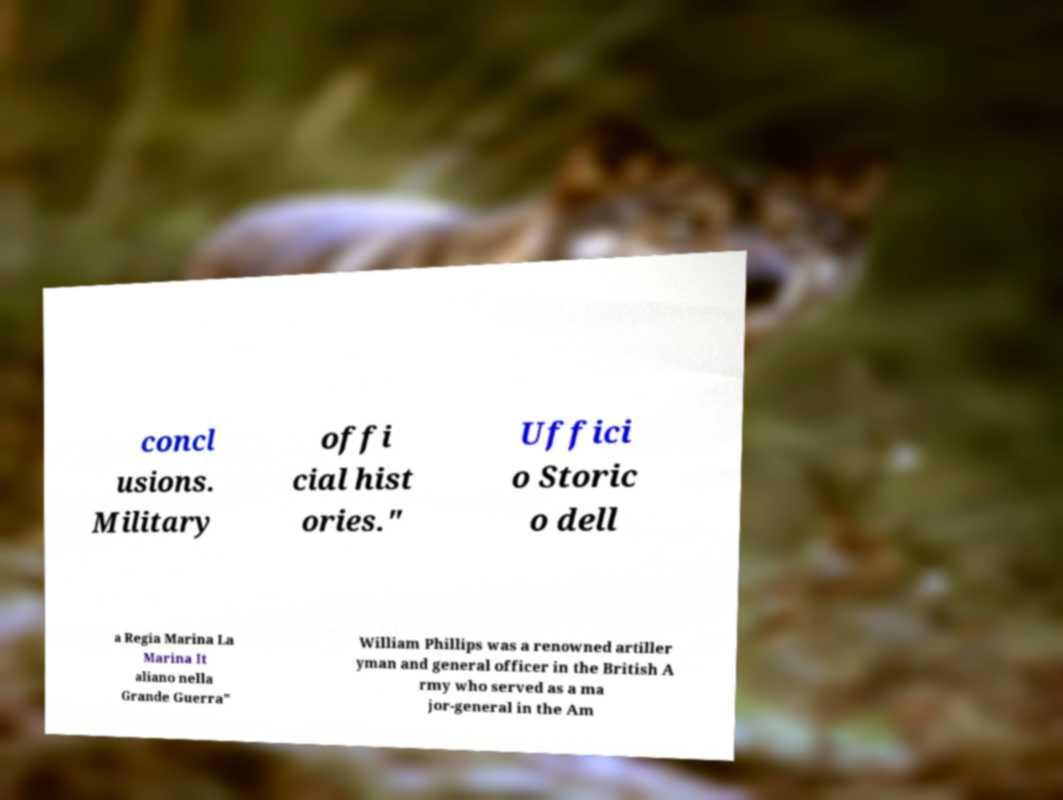There's text embedded in this image that I need extracted. Can you transcribe it verbatim? concl usions. Military offi cial hist ories." Uffici o Storic o dell a Regia Marina La Marina It aliano nella Grande Guerra" William Phillips was a renowned artiller yman and general officer in the British A rmy who served as a ma jor-general in the Am 